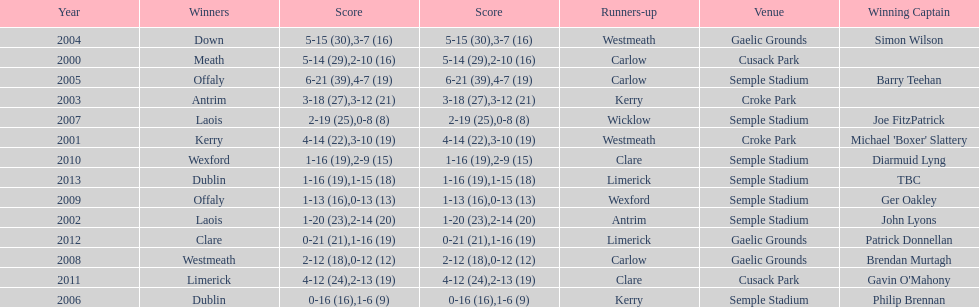Who was the winning captain the last time the competition was held at the gaelic grounds venue? Patrick Donnellan. 